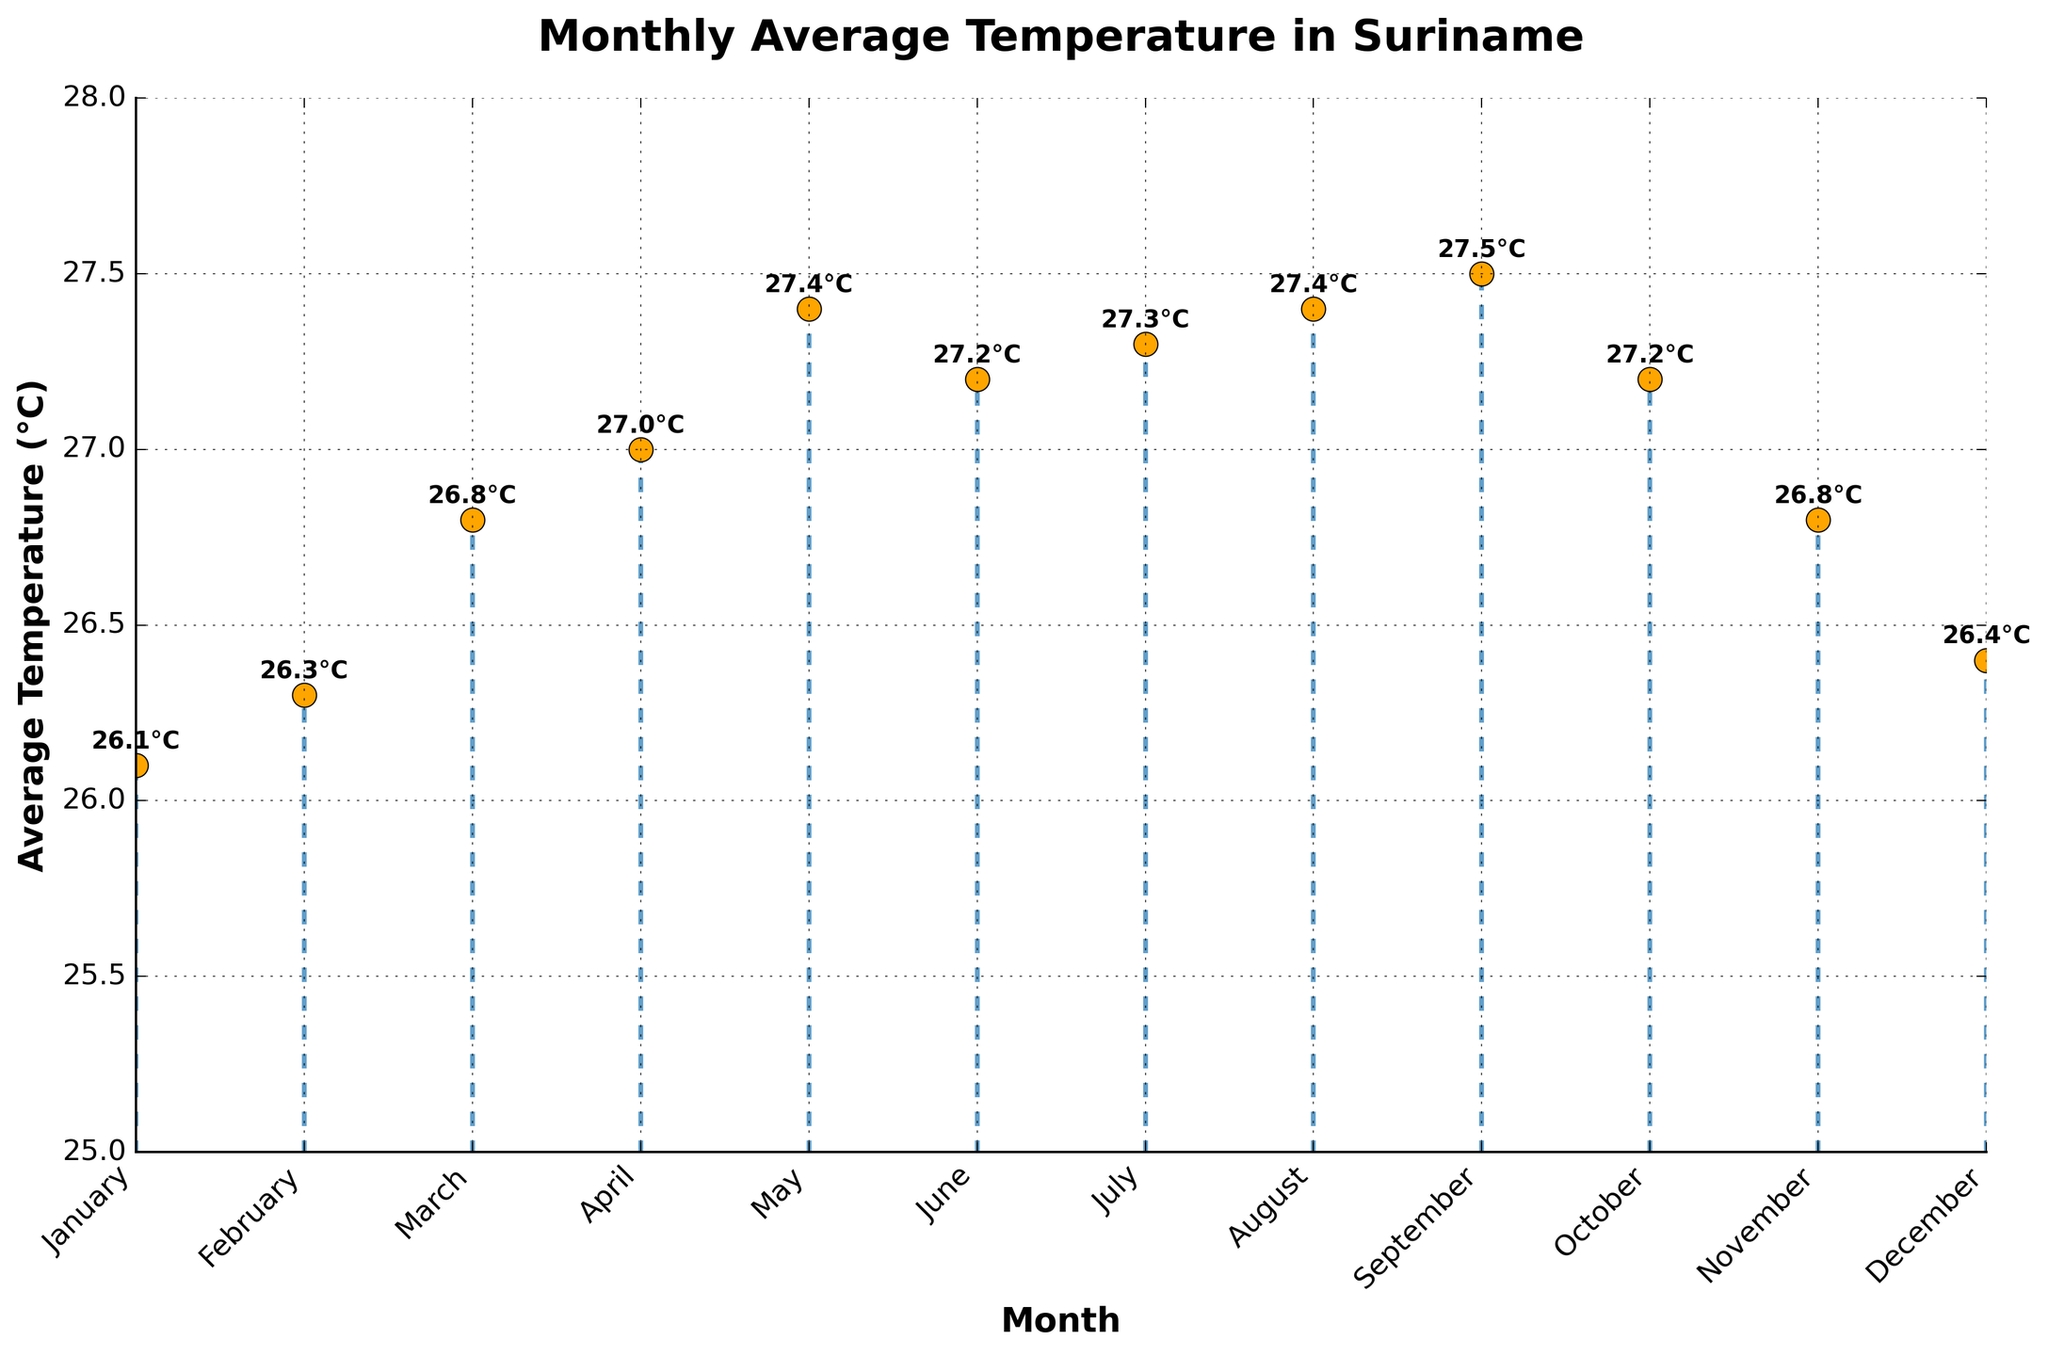What is the title of the plot? The title is usually placed at the top of the figure, in larger and bold font. It typically summarizes the main topic of the figure.
Answer: Monthly Average Temperature in Suriname What are the units on the vertical axis? The units on the vertical axis are often indicated next to the axis label, specifying the measurement being plotted.
Answer: °C Which month has the highest average temperature? By looking at the heights of the stems, we can see that the highest point is in September.
Answer: September How many months have an average temperature above 27°C? By examining the stem heights and noting which ones exceed the 27°C mark on the vertical axis, we count the number of such months.
Answer: 4 What is the average temperature in February? Look at the label for February on the horizontal axis and follow its stem to the point where it intersects with the temperature value.
Answer: 26.3°C What is the temperature difference between the warmest and coolest months? Identify the highest and lowest points on the stem plot and subtract the lowest average from the highest average temperature. The warmest month is September (27.5°C), and the coolest month is January (26.1°C). Calculation: 27.5 - 26.1 = 1.4
Answer: 1.4°C Which months have the same average temperature of 27.4°C? Locate the stems reaching the 27.4°C mark and check their corresponding months on the horizontal axis.
Answer: May and August How does the temperature trend as the year progresses? Observe the general pattern of stem heights from left to right. Initially, the temperature increases, reaches a peak, and then slightly decreases.
Answer: Increases, peaks, then slightly decreases Does the plot have any clear seasonal patterns? If yes, describe them. By visually assessing the plot, we observe that temperatures generally rise from January to September and then fall towards December, indicating a seasonal warming and cooling pattern.
Answer: Yes, it shows an increase from January to September, then a decrease towards December What is the overall range of temperatures shown on the plot? Note the lowest and highest values on the vertical axis and find their range by subtracting the minimum average temperature from the maximum average temperature.
Answer: 26.1°C to 27.5°C 